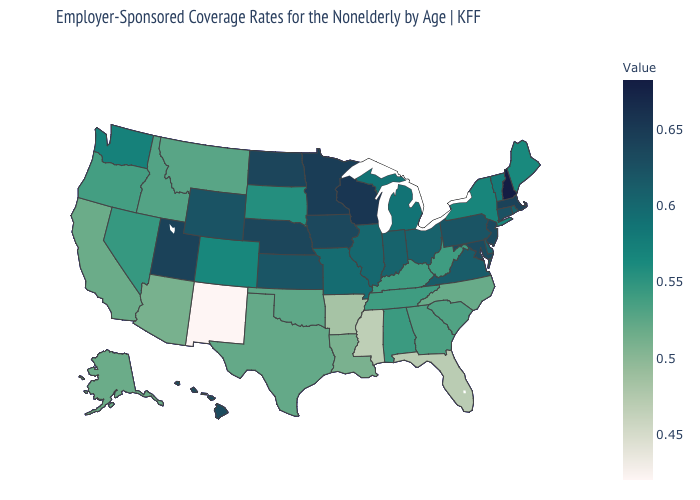Which states have the lowest value in the Northeast?
Give a very brief answer. Maine. Which states have the lowest value in the MidWest?
Give a very brief answer. South Dakota. Does Indiana have the lowest value in the MidWest?
Short answer required. No. Does Oklahoma have a higher value than North Dakota?
Write a very short answer. No. Among the states that border Iowa , which have the lowest value?
Write a very short answer. South Dakota. Among the states that border Colorado , which have the highest value?
Quick response, please. Utah. Does Tennessee have a higher value than Vermont?
Write a very short answer. No. 